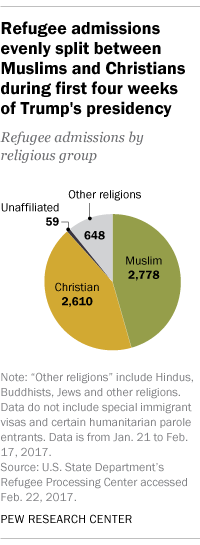Draw attention to some important aspects in this diagram. We take the difference between the two largest segments, add it to the smallest segment, and the result is 227. According to the data, Muslim refugees make up the majority of the 2778 refugee admissions. 